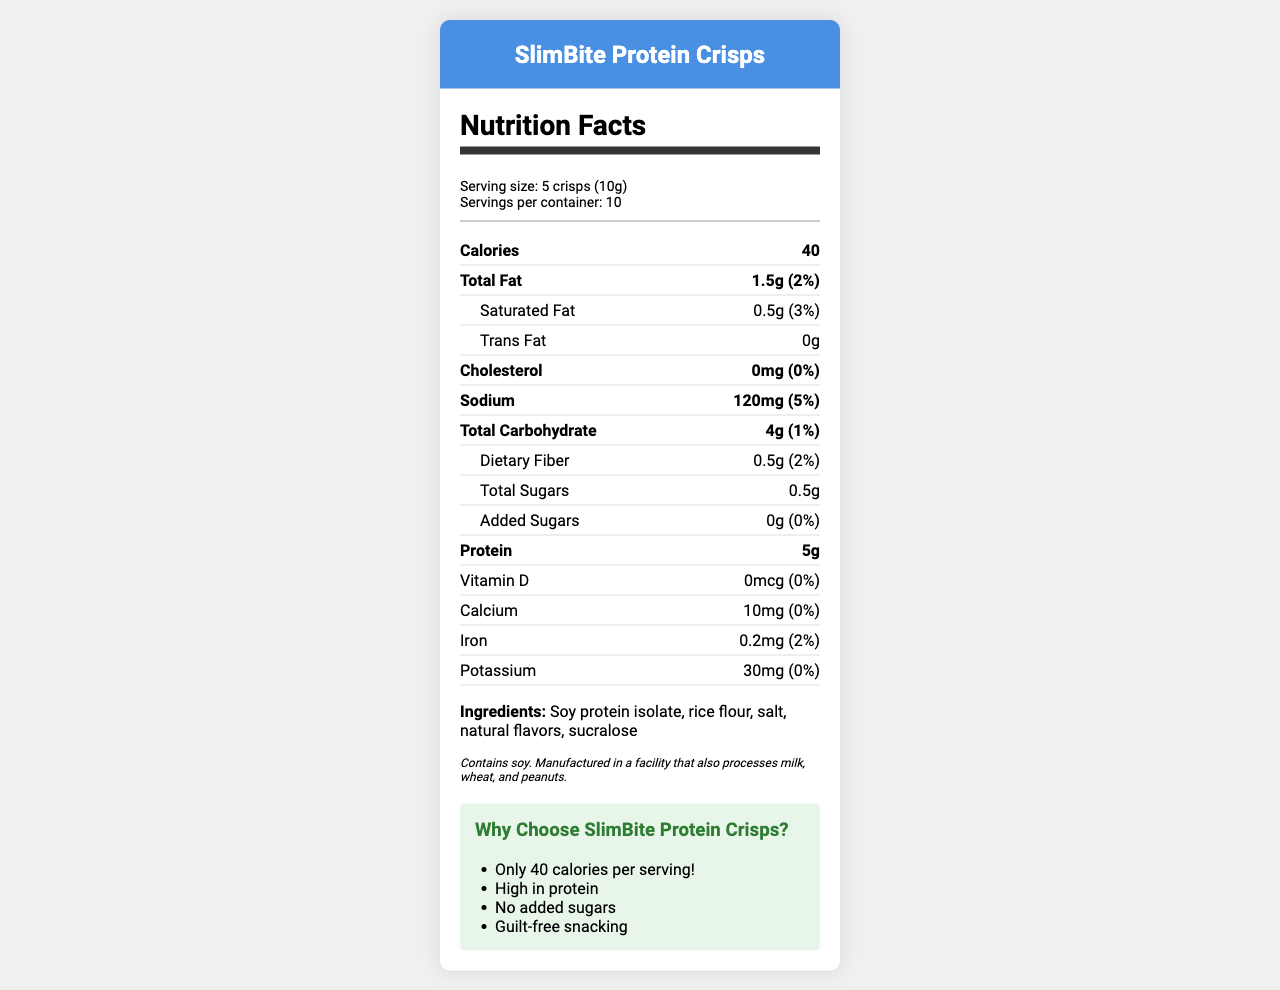what is the product name? The product name is located at the top of the document under the header section.
Answer: SlimBite Protein Crisps what is the serving size for SlimBite Protein Crisps? The serving size is listed in the serving information section.
Answer: 5 crisps (10g) how many calories are there per serving? The calories per serving are prominently displayed in the nutrient rows under the Calories header.
Answer: 40 what are the main ingredients of SlimBite Protein Crisps? The main ingredients are listed at the bottom of the document under the Ingredients section.
Answer: Soy protein isolate, rice flour, salt, natural flavors, sucralose what is the actual package weight of SlimBite Protein Crisps? The actual package weight is provided in the additional data section outside the nutrition facts provided.
Answer: 200g what percentage of the daily value of sodium is in one serving? The sodium content and its daily value percentage are mentioned in the nutrient row for sodium.
Answer: 5% what is the amount of saturated fat per serving? The amount of saturated fat is listed in the nutrient rows under the indent section for saturated fat.
Answer: 0.5g how many grams of protein are in one serving? The protein content is displayed in the bold nutrient rows under the Protein header.
Answer: 5g which of these is a marketing claim for SlimBite Protein Crisps? A. Contains vitamins B. Low-calorie C. High in protein D. Gluten-free The document displays various marketing claims, including "High in protein."
Answer: C how much dietary fiber does one serving contain? A. 0g B. 0.5g C. 1g D. 2g According to the document, one serving contains 0.5g of dietary fiber.
Answer: B does this product contain any trans fat? The document states "0g" for trans fat under the Trans Fat section.
Answer: No describe the main idea of the nutrition facts label for SlimBite Protein Crisps. The document presents the nutritional information in a clear and organized manner, summarizing the key nutritional aspects and additional product details to help consumers make informed choices.
Answer: The nutrition facts label for SlimBite Protein Crisps provides detailed information about the product's nutritional content per serving, including calorie count, fat content, sodium, carbohydrates, protein, vitamins, and minerals. It also highlights key marketing claims and provides allergen information. Additionally, the actual package weight and a realistic serving size with corresponding calorie count are mentioned. what is the actual calorie count for a realistic serving size of 50g? The realistic serving size and its corresponding calorie count are specified as 50g and 200 calories respectively in the additional data section.
Answer: 200 how many calories are there in the entire container? Given that there are 10 servings per container and each serving has 40 calories, the total calories in the entire container are 40 * 10 = 400.
Answer: 400 can the presence of gluten be determined from the document? The document does not provide specific information about the presence or absence of gluten. The allergen information only mentions soy, milk, wheat, and peanuts processing.
Answer: Cannot be determined how much calcium is found in a serving of SlimBite Protein Crisps? The amount of calcium per serving is listed in the rows for minerals and vitamins under Calcium.
Answer: 10mg 